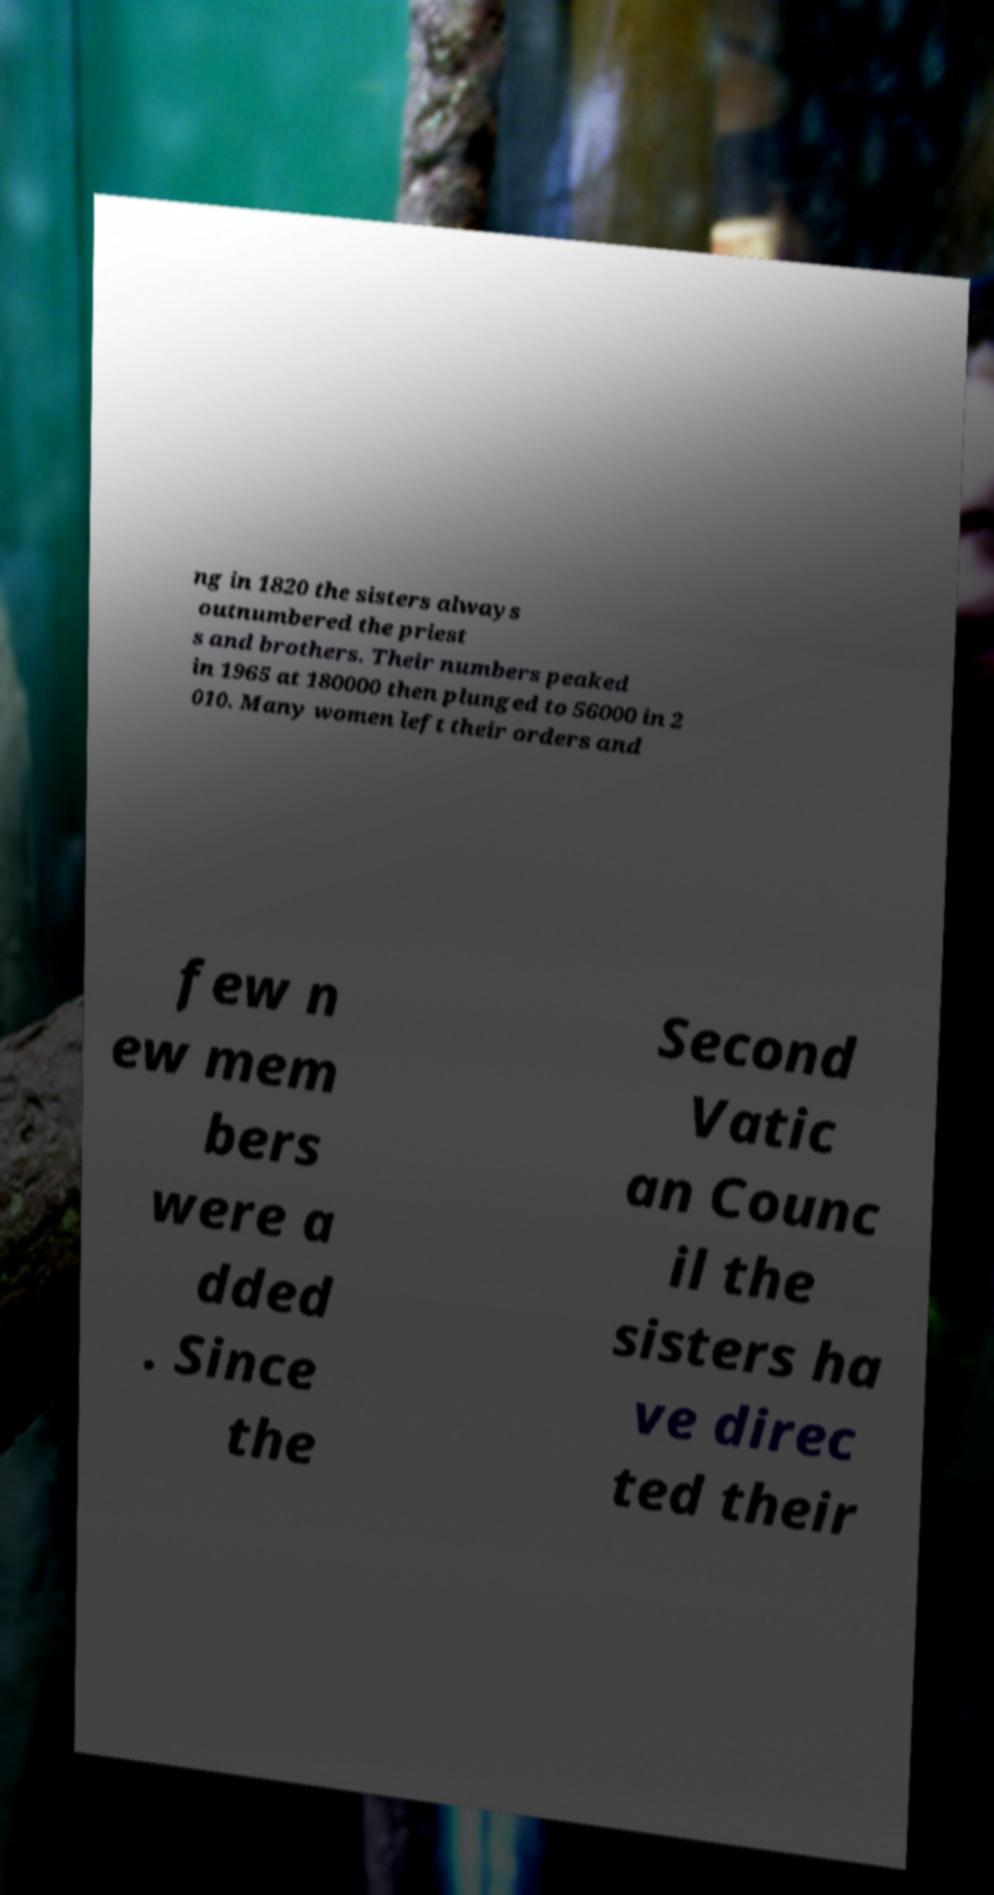For documentation purposes, I need the text within this image transcribed. Could you provide that? ng in 1820 the sisters always outnumbered the priest s and brothers. Their numbers peaked in 1965 at 180000 then plunged to 56000 in 2 010. Many women left their orders and few n ew mem bers were a dded . Since the Second Vatic an Counc il the sisters ha ve direc ted their 